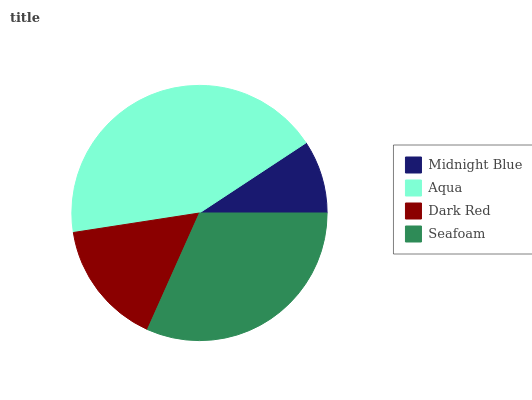Is Midnight Blue the minimum?
Answer yes or no. Yes. Is Aqua the maximum?
Answer yes or no. Yes. Is Dark Red the minimum?
Answer yes or no. No. Is Dark Red the maximum?
Answer yes or no. No. Is Aqua greater than Dark Red?
Answer yes or no. Yes. Is Dark Red less than Aqua?
Answer yes or no. Yes. Is Dark Red greater than Aqua?
Answer yes or no. No. Is Aqua less than Dark Red?
Answer yes or no. No. Is Seafoam the high median?
Answer yes or no. Yes. Is Dark Red the low median?
Answer yes or no. Yes. Is Midnight Blue the high median?
Answer yes or no. No. Is Midnight Blue the low median?
Answer yes or no. No. 